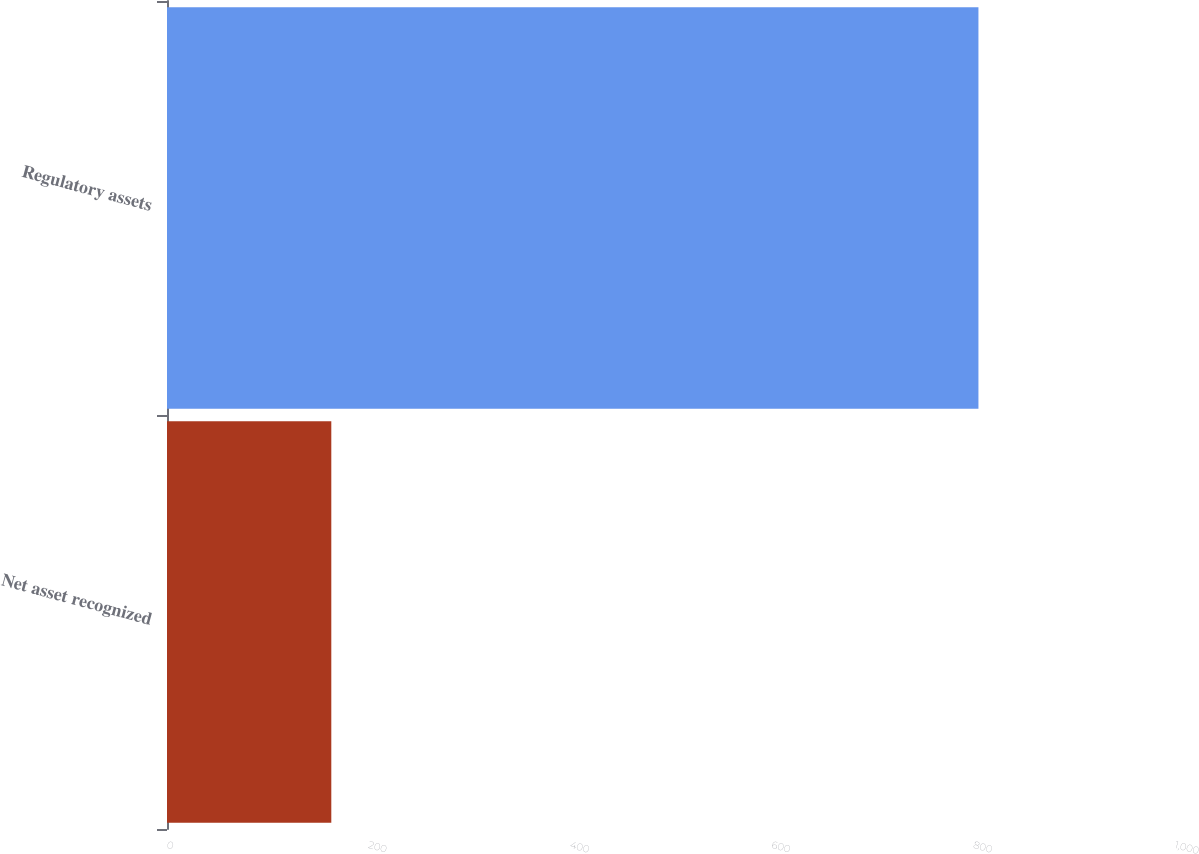Convert chart. <chart><loc_0><loc_0><loc_500><loc_500><bar_chart><fcel>Net asset recognized<fcel>Regulatory assets<nl><fcel>163<fcel>805<nl></chart> 